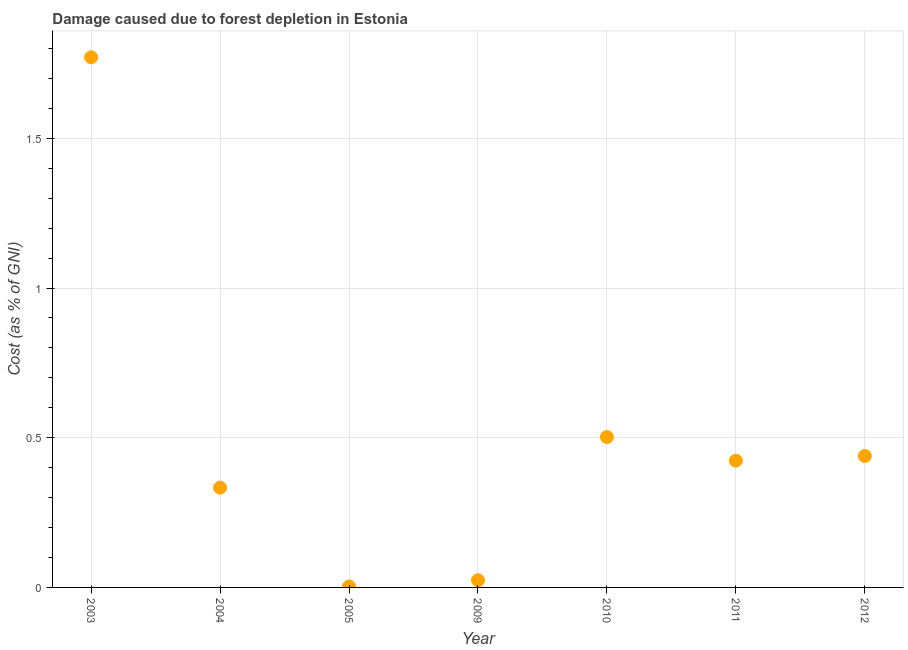What is the damage caused due to forest depletion in 2003?
Provide a succinct answer. 1.77. Across all years, what is the maximum damage caused due to forest depletion?
Ensure brevity in your answer.  1.77. Across all years, what is the minimum damage caused due to forest depletion?
Provide a succinct answer. 0. In which year was the damage caused due to forest depletion minimum?
Offer a terse response. 2005. What is the sum of the damage caused due to forest depletion?
Your answer should be very brief. 3.5. What is the difference between the damage caused due to forest depletion in 2003 and 2010?
Keep it short and to the point. 1.27. What is the average damage caused due to forest depletion per year?
Make the answer very short. 0.5. What is the median damage caused due to forest depletion?
Your response must be concise. 0.42. In how many years, is the damage caused due to forest depletion greater than 1.1 %?
Offer a very short reply. 1. What is the ratio of the damage caused due to forest depletion in 2005 to that in 2012?
Your answer should be very brief. 0.01. Is the damage caused due to forest depletion in 2005 less than that in 2010?
Make the answer very short. Yes. What is the difference between the highest and the second highest damage caused due to forest depletion?
Your response must be concise. 1.27. Is the sum of the damage caused due to forest depletion in 2004 and 2005 greater than the maximum damage caused due to forest depletion across all years?
Provide a short and direct response. No. What is the difference between the highest and the lowest damage caused due to forest depletion?
Ensure brevity in your answer.  1.77. How many dotlines are there?
Ensure brevity in your answer.  1. How many years are there in the graph?
Your response must be concise. 7. Are the values on the major ticks of Y-axis written in scientific E-notation?
Offer a very short reply. No. What is the title of the graph?
Offer a terse response. Damage caused due to forest depletion in Estonia. What is the label or title of the X-axis?
Provide a short and direct response. Year. What is the label or title of the Y-axis?
Your answer should be very brief. Cost (as % of GNI). What is the Cost (as % of GNI) in 2003?
Provide a succinct answer. 1.77. What is the Cost (as % of GNI) in 2004?
Offer a very short reply. 0.33. What is the Cost (as % of GNI) in 2005?
Make the answer very short. 0. What is the Cost (as % of GNI) in 2009?
Your answer should be compact. 0.02. What is the Cost (as % of GNI) in 2010?
Offer a very short reply. 0.5. What is the Cost (as % of GNI) in 2011?
Provide a short and direct response. 0.42. What is the Cost (as % of GNI) in 2012?
Offer a terse response. 0.44. What is the difference between the Cost (as % of GNI) in 2003 and 2004?
Offer a terse response. 1.44. What is the difference between the Cost (as % of GNI) in 2003 and 2005?
Your response must be concise. 1.77. What is the difference between the Cost (as % of GNI) in 2003 and 2009?
Your answer should be very brief. 1.75. What is the difference between the Cost (as % of GNI) in 2003 and 2010?
Keep it short and to the point. 1.27. What is the difference between the Cost (as % of GNI) in 2003 and 2011?
Provide a succinct answer. 1.35. What is the difference between the Cost (as % of GNI) in 2003 and 2012?
Offer a very short reply. 1.33. What is the difference between the Cost (as % of GNI) in 2004 and 2005?
Ensure brevity in your answer.  0.33. What is the difference between the Cost (as % of GNI) in 2004 and 2009?
Keep it short and to the point. 0.31. What is the difference between the Cost (as % of GNI) in 2004 and 2010?
Give a very brief answer. -0.17. What is the difference between the Cost (as % of GNI) in 2004 and 2011?
Provide a short and direct response. -0.09. What is the difference between the Cost (as % of GNI) in 2004 and 2012?
Offer a terse response. -0.11. What is the difference between the Cost (as % of GNI) in 2005 and 2009?
Keep it short and to the point. -0.02. What is the difference between the Cost (as % of GNI) in 2005 and 2010?
Your response must be concise. -0.5. What is the difference between the Cost (as % of GNI) in 2005 and 2011?
Your answer should be very brief. -0.42. What is the difference between the Cost (as % of GNI) in 2005 and 2012?
Offer a very short reply. -0.44. What is the difference between the Cost (as % of GNI) in 2009 and 2010?
Offer a terse response. -0.48. What is the difference between the Cost (as % of GNI) in 2009 and 2011?
Give a very brief answer. -0.4. What is the difference between the Cost (as % of GNI) in 2009 and 2012?
Your response must be concise. -0.42. What is the difference between the Cost (as % of GNI) in 2010 and 2011?
Offer a very short reply. 0.08. What is the difference between the Cost (as % of GNI) in 2010 and 2012?
Your response must be concise. 0.06. What is the difference between the Cost (as % of GNI) in 2011 and 2012?
Give a very brief answer. -0.02. What is the ratio of the Cost (as % of GNI) in 2003 to that in 2004?
Your answer should be very brief. 5.31. What is the ratio of the Cost (as % of GNI) in 2003 to that in 2005?
Make the answer very short. 595.25. What is the ratio of the Cost (as % of GNI) in 2003 to that in 2009?
Offer a very short reply. 74.08. What is the ratio of the Cost (as % of GNI) in 2003 to that in 2010?
Your response must be concise. 3.52. What is the ratio of the Cost (as % of GNI) in 2003 to that in 2011?
Your answer should be very brief. 4.18. What is the ratio of the Cost (as % of GNI) in 2003 to that in 2012?
Provide a short and direct response. 4.03. What is the ratio of the Cost (as % of GNI) in 2004 to that in 2005?
Give a very brief answer. 112.03. What is the ratio of the Cost (as % of GNI) in 2004 to that in 2009?
Provide a short and direct response. 13.94. What is the ratio of the Cost (as % of GNI) in 2004 to that in 2010?
Offer a terse response. 0.66. What is the ratio of the Cost (as % of GNI) in 2004 to that in 2011?
Give a very brief answer. 0.79. What is the ratio of the Cost (as % of GNI) in 2004 to that in 2012?
Your response must be concise. 0.76. What is the ratio of the Cost (as % of GNI) in 2005 to that in 2009?
Offer a very short reply. 0.12. What is the ratio of the Cost (as % of GNI) in 2005 to that in 2010?
Make the answer very short. 0.01. What is the ratio of the Cost (as % of GNI) in 2005 to that in 2011?
Give a very brief answer. 0.01. What is the ratio of the Cost (as % of GNI) in 2005 to that in 2012?
Ensure brevity in your answer.  0.01. What is the ratio of the Cost (as % of GNI) in 2009 to that in 2010?
Offer a very short reply. 0.05. What is the ratio of the Cost (as % of GNI) in 2009 to that in 2011?
Give a very brief answer. 0.06. What is the ratio of the Cost (as % of GNI) in 2009 to that in 2012?
Give a very brief answer. 0.05. What is the ratio of the Cost (as % of GNI) in 2010 to that in 2011?
Keep it short and to the point. 1.19. What is the ratio of the Cost (as % of GNI) in 2010 to that in 2012?
Keep it short and to the point. 1.14. 